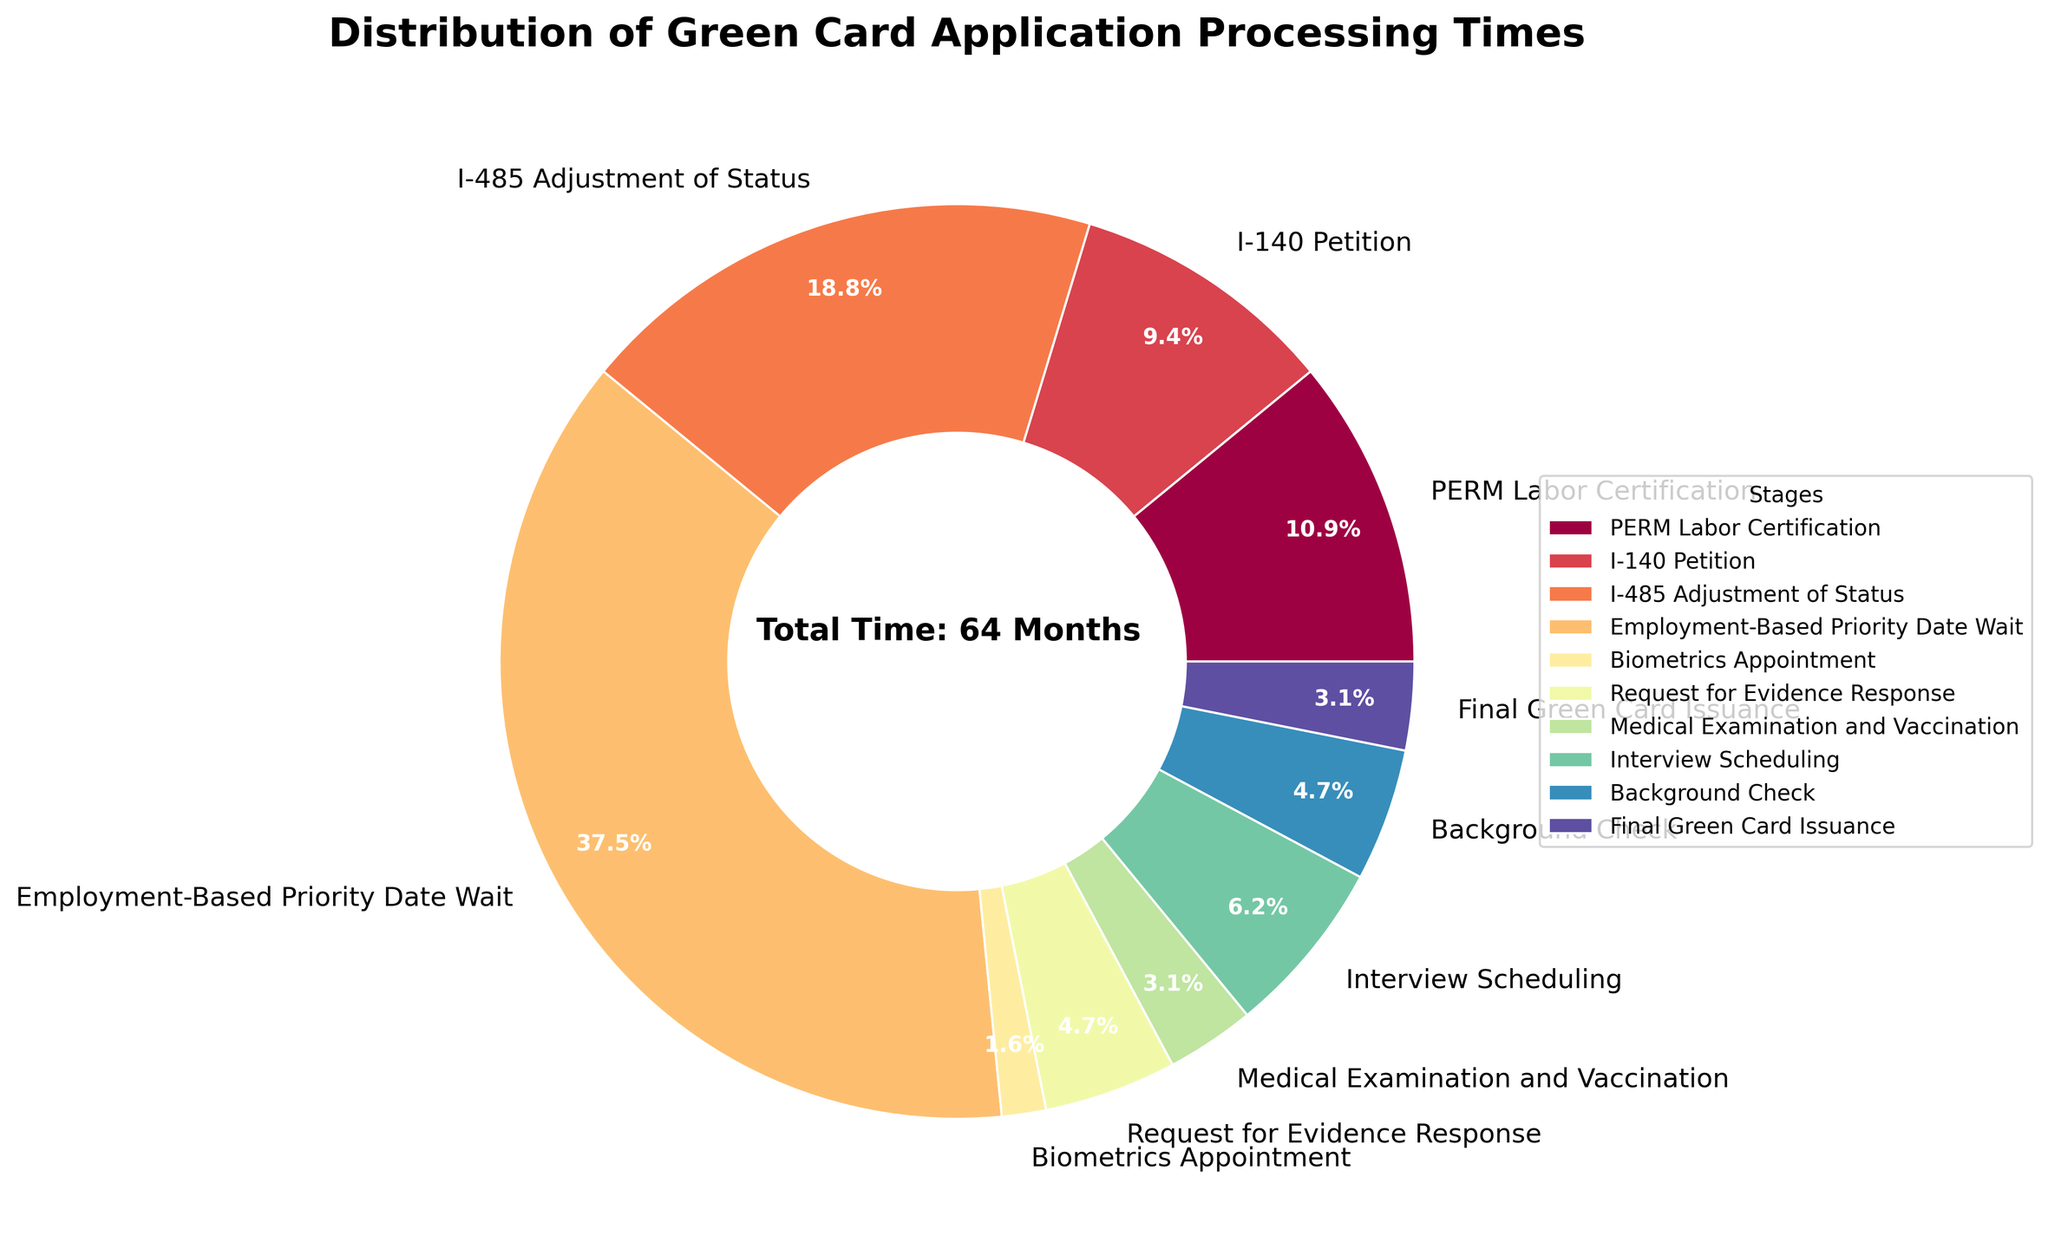What is the stage with the longest average processing time? From the pie chart, identify the stage with the largest slice, representing the longest average processing time.
Answer: Employment-Based Priority Date Wait Which stage has the shortest average processing time? From the pie chart, identify the stage with the smallest slice, representing the shortest average processing time.
Answer: Biometrics Appointment What is the combined average processing time for the I-140 Petition and I-485 Adjustment of Status stages? Add the average processing times for I-140 Petition (6 months) and I-485 Adjustment of Status (12 months).
Answer: 18 months Is the average processing time for the Interview Scheduling stage greater than that for the Medical Examination and Vaccination stage? Compare the average processing times of both stages from the chart. Interview Scheduling is 4 months, while Medical Examination and Vaccination is 2 months.
Answer: Yes What percentage of the total processing time is taken up by the PERM Labor Certification and Background Check stages combined? First, add the average times for PERM Labor Certification (7 months) and Background Check (3 months) to get a total of 10 months. Then, divide this by the total processing time and multiply by 100 to get the percentage. Total time is 64 months. (10/64)*100 = 15.6%.
Answer: 15.6% Which stage has a visually similar slice size to the Request for Evidence Response stage? Visually inspect the chart to find a stage with a slice approximately the same size as the slice for Request for Evidence Response (3 months). Background Check also has an average processing time of 3 months, hence a visually similar slice.
Answer: Background Check How much more time does it take to complete the Employment-Based Priority Date Wait stage compared to the I-140 Petition, I-485 Adjustment of Status, and Biometrics Appointment stages combined? First, find the combined time for I-140 Petition (6), I-485 Adjustment of Status (12), and Biometrics Appointment (1), which is 19 months. Then subtract this from the Employment-Based Priority Date Wait (24 months). 24 - 19 = 5.
Answer: 5 months If you were able to expedite the stages of I-485 Adjustment of Status and Final Green Card Issuance by 2 months each, what would be the new total processing time? Subtract 2 months each from I-485 Adjustment of Status (12->10) and Final Green Card Issuance (2->0). Then sum the new times: PERM Labor Certification (7), I-140 Petition (6), I-485 Adjustment of Status (10), Employment-Based Priority Date Wait (24), Biometrics Appointment (1), Request for Evidence Response (3), Medical Examination and Vaccination (2), Interview Scheduling (4), Background Check (3), and Final Green Card Issuance (0). New total time = 60 months.
Answer: 60 months Between which stages do you notice the most significant difference in their average processing times? Compare the average processing times to see the largest difference. Employment-Based Priority Date Wait (24 months) significantly differs from Biometrics Appointment (1 month).
Answer: Employment-Based Priority Date Wait and Biometrics Appointment What is the percentage of the total time that the I-140 Petition stage takes up? Divide the average time for the I-140 Petition stage (6 months) by the total processing time (64 months) and multiply by 100. (6/64)*100 = 9.4%.
Answer: 9.4% 